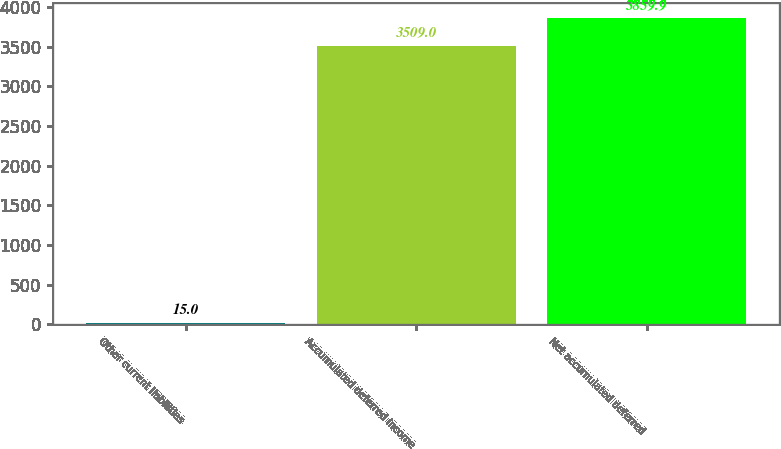<chart> <loc_0><loc_0><loc_500><loc_500><bar_chart><fcel>Other current liabilities<fcel>Accumulated deferred income<fcel>Net accumulated deferred<nl><fcel>15<fcel>3509<fcel>3859.9<nl></chart> 